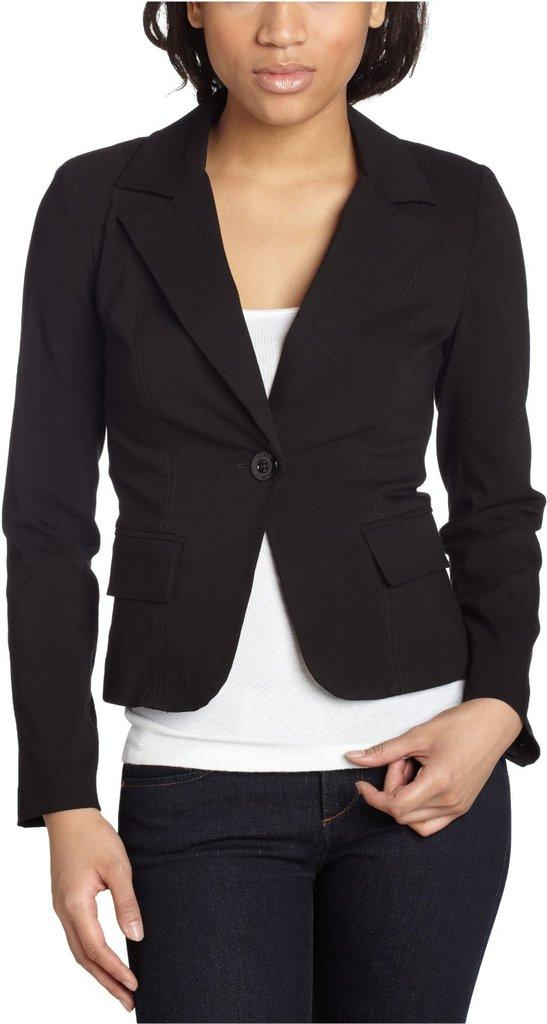What is the main subject of the image? There is a person standing in the image. What can be observed about the background of the image? The background of the image is white. How many snails are crawling on the person's veil in the image? There is no veil or snails present in the image. What type of beetle can be seen on the person's shoulder in the image? There is no beetle present in the image. 